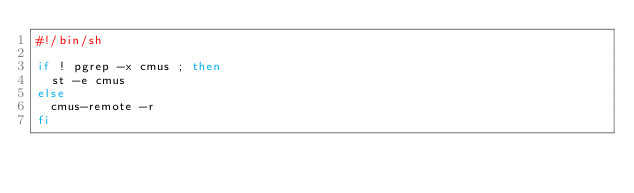Convert code to text. <code><loc_0><loc_0><loc_500><loc_500><_Bash_>#!/bin/sh

if ! pgrep -x cmus ; then
  st -e cmus
else
  cmus-remote -r
fi
</code> 